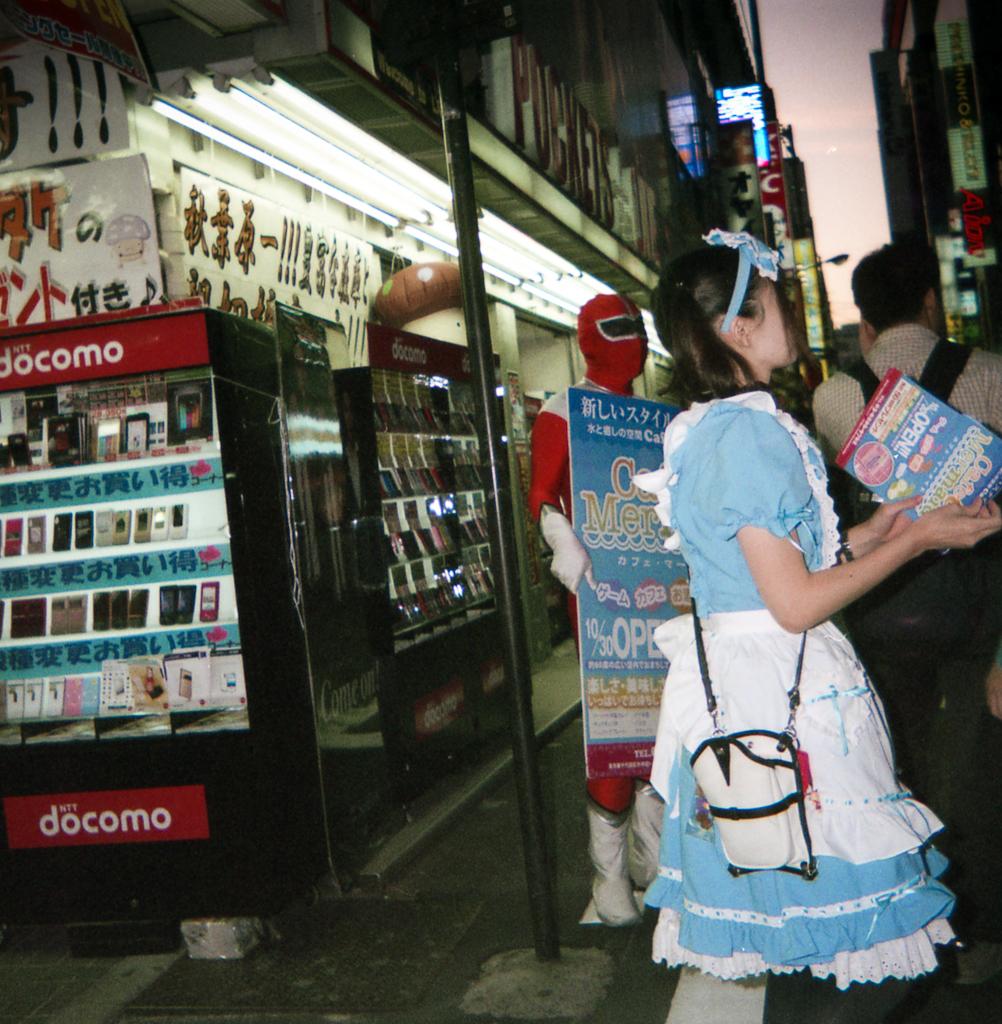What does the red sign say?
Offer a terse response. Docomo. 